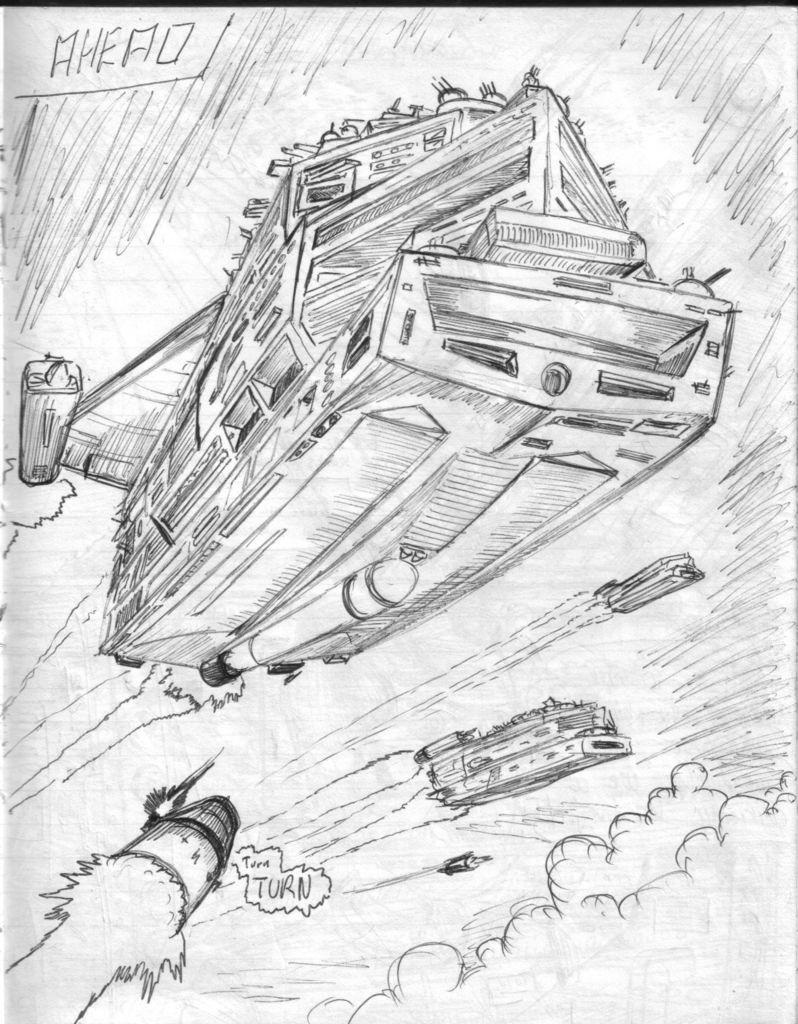What is the main subject of the drawing in the image? There is a drawing of spaceships in the image. Where are the spaceships located in the drawing? The spaceships are depicted in the sky. What is the medium of the drawing? The drawing is on a paper. How many eyes can be seen on the deer in the image? There is no deer present in the image; it features a drawing of spaceships in the sky. 